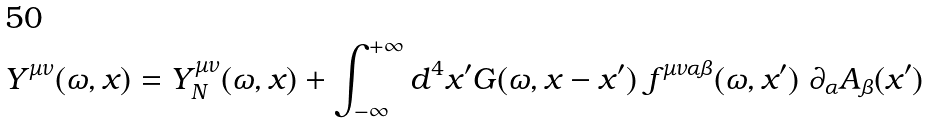<formula> <loc_0><loc_0><loc_500><loc_500>Y ^ { \mu \nu } ( \omega , x ) = Y _ { N } ^ { \mu \nu } ( \omega , x ) + \int _ { - \infty } ^ { + \infty } d ^ { 4 } x ^ { \prime } G ( \omega , x - x ^ { \prime } ) \ f ^ { \mu \nu \alpha \beta } ( \omega , x ^ { \prime } ) \ \partial _ { \alpha } A _ { \beta } ( x ^ { \prime } )</formula> 